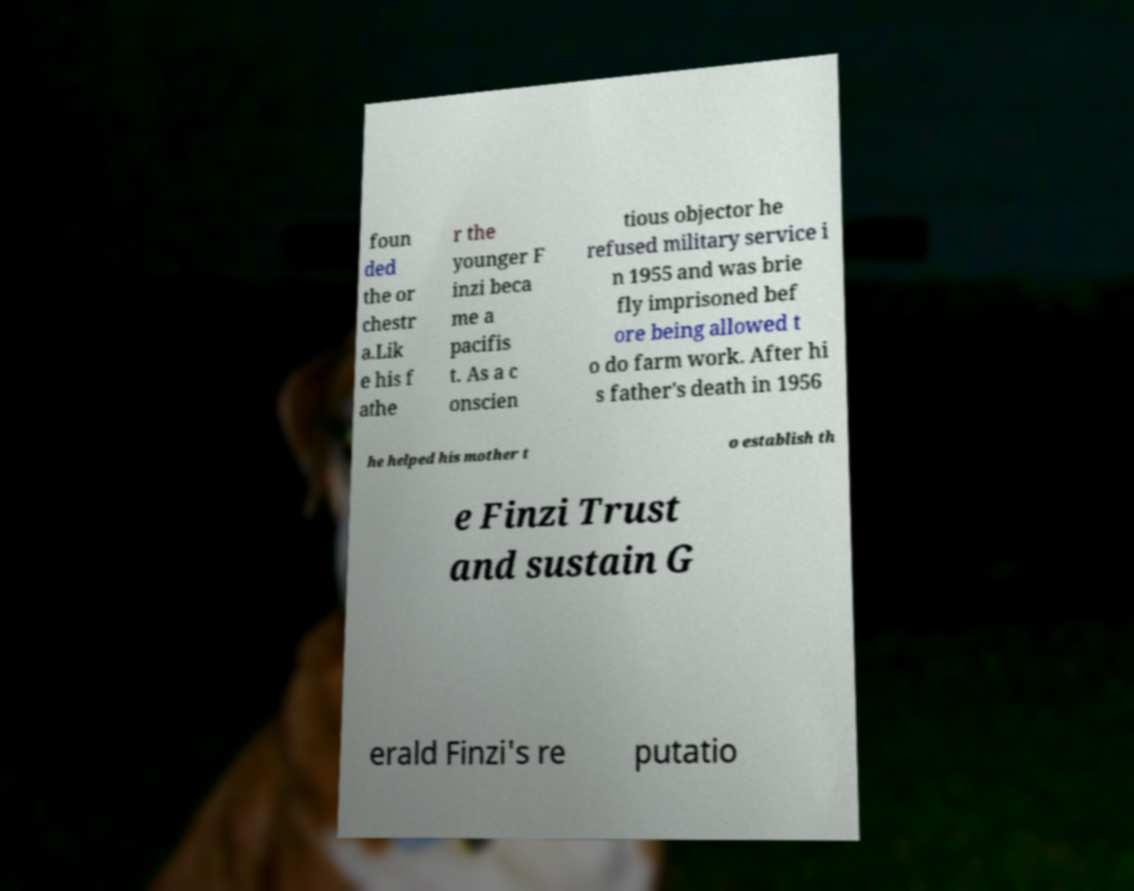What messages or text are displayed in this image? I need them in a readable, typed format. foun ded the or chestr a.Lik e his f athe r the younger F inzi beca me a pacifis t. As a c onscien tious objector he refused military service i n 1955 and was brie fly imprisoned bef ore being allowed t o do farm work. After hi s father's death in 1956 he helped his mother t o establish th e Finzi Trust and sustain G erald Finzi's re putatio 